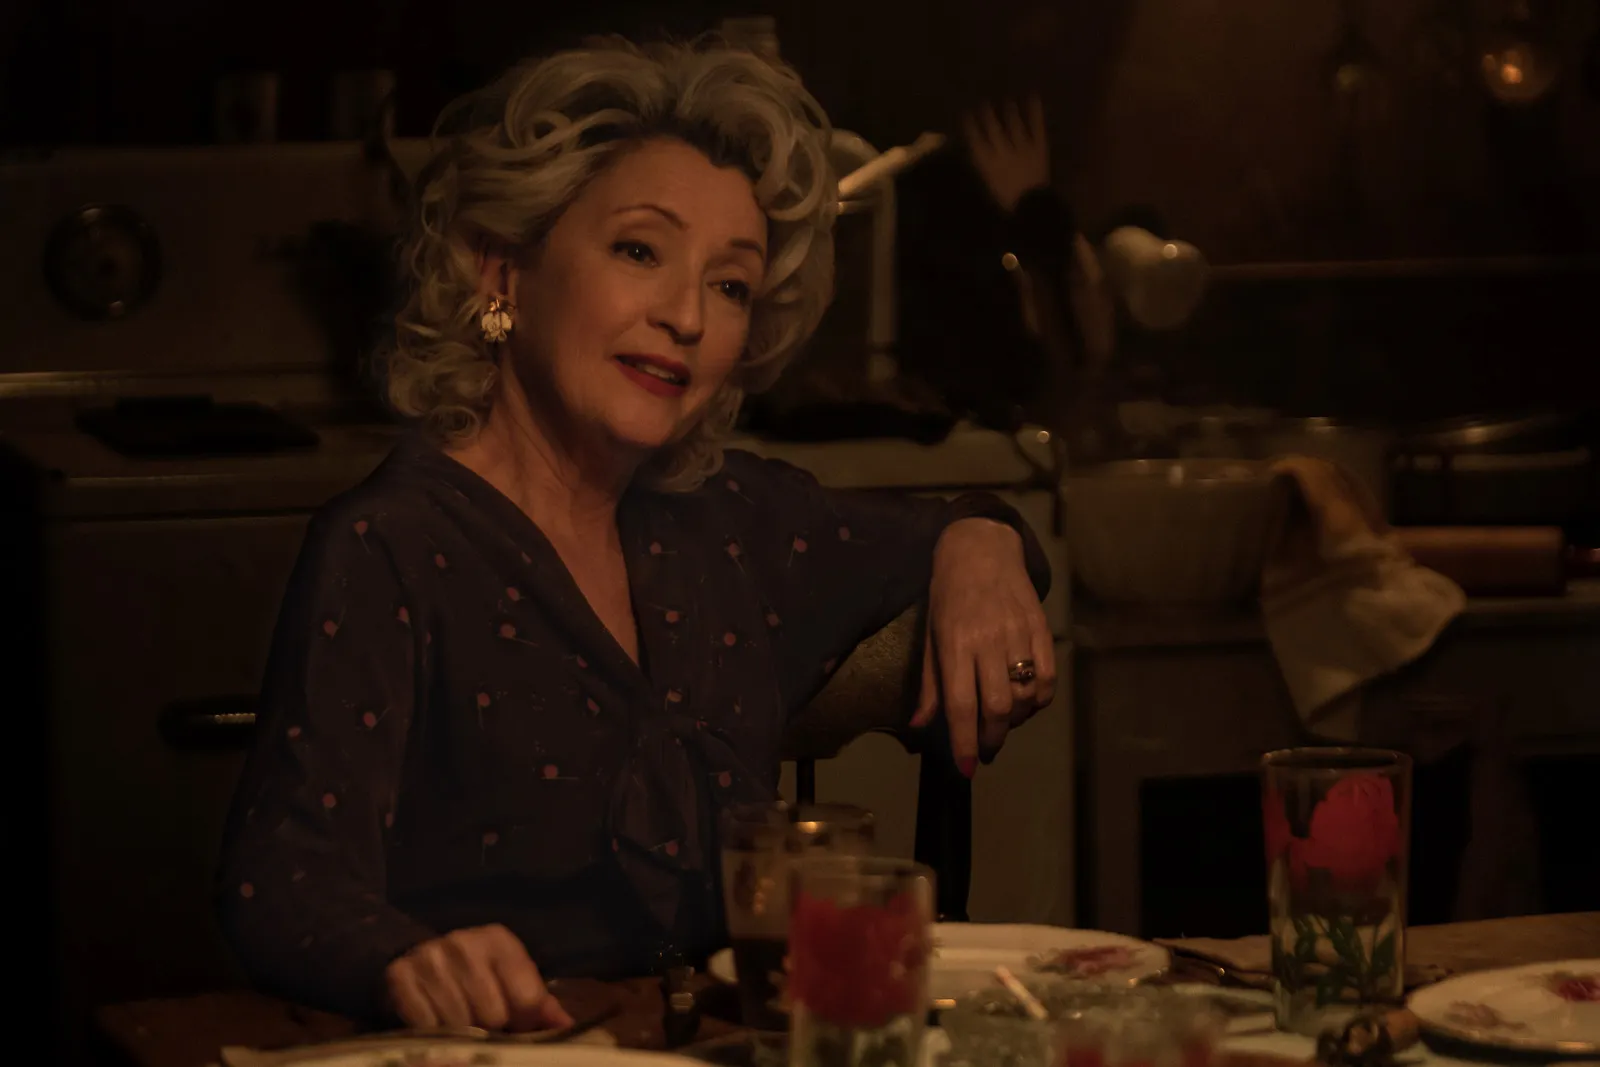What can you infer about the woman's personality from this image? Based on the image, the woman exudes a sense of quiet confidence and contentment. Her serene expression and relaxed posture at the dining table, amidst a warmly lit setting, suggest a personality that appreciates and finds comfort in the simple pleasures of life, like a home-cooked meal. 